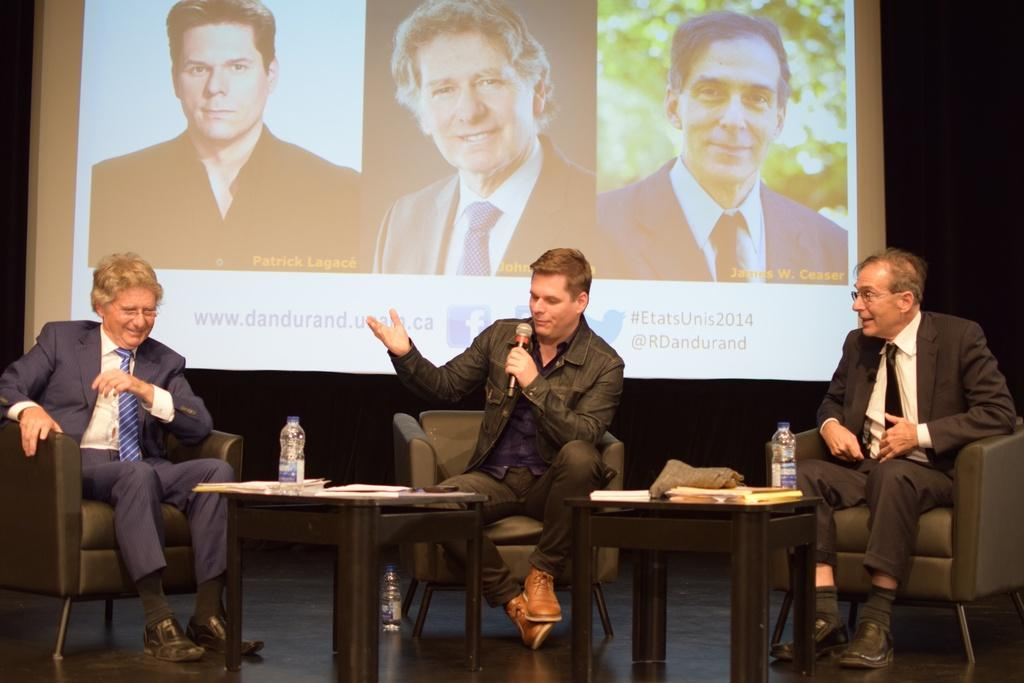How many people are present in the image? There are three people in the image. What are the people doing in the image? The people are sitting on chairs. What is on the table in the image? There are papers and a bottle on the table. Can you describe the table in the image? There is a table in the image. What type of day is depicted in the image? The provided facts do not mention any specific day or time of day, so it cannot be determined from the image. Can you describe the shape of the bottle on the table? The provided facts do not mention the shape of the bottle, only that it is present on the table. 